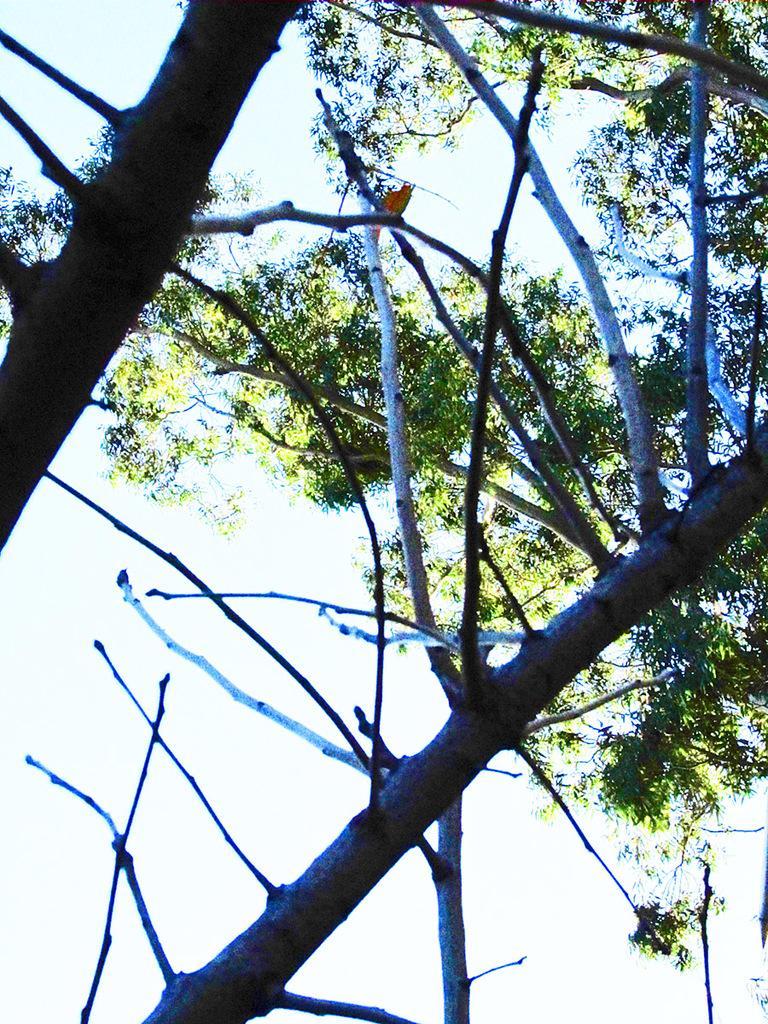Describe this image in one or two sentences. In this image we can see dried branches of a tree, behind the dry branches there is another tree. 